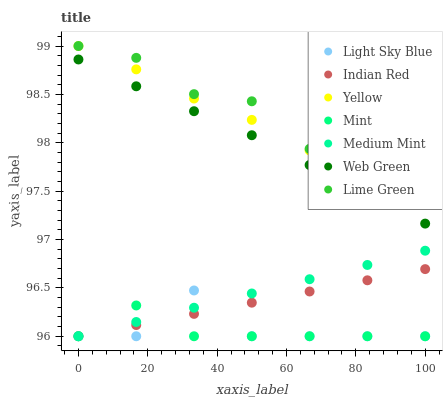Does Mint have the minimum area under the curve?
Answer yes or no. Yes. Does Lime Green have the maximum area under the curve?
Answer yes or no. Yes. Does Web Green have the minimum area under the curve?
Answer yes or no. No. Does Web Green have the maximum area under the curve?
Answer yes or no. No. Is Indian Red the smoothest?
Answer yes or no. Yes. Is Light Sky Blue the roughest?
Answer yes or no. Yes. Is Lime Green the smoothest?
Answer yes or no. No. Is Lime Green the roughest?
Answer yes or no. No. Does Medium Mint have the lowest value?
Answer yes or no. Yes. Does Web Green have the lowest value?
Answer yes or no. No. Does Yellow have the highest value?
Answer yes or no. Yes. Does Web Green have the highest value?
Answer yes or no. No. Is Web Green less than Yellow?
Answer yes or no. Yes. Is Yellow greater than Medium Mint?
Answer yes or no. Yes. Does Medium Mint intersect Light Sky Blue?
Answer yes or no. Yes. Is Medium Mint less than Light Sky Blue?
Answer yes or no. No. Is Medium Mint greater than Light Sky Blue?
Answer yes or no. No. Does Web Green intersect Yellow?
Answer yes or no. No. 